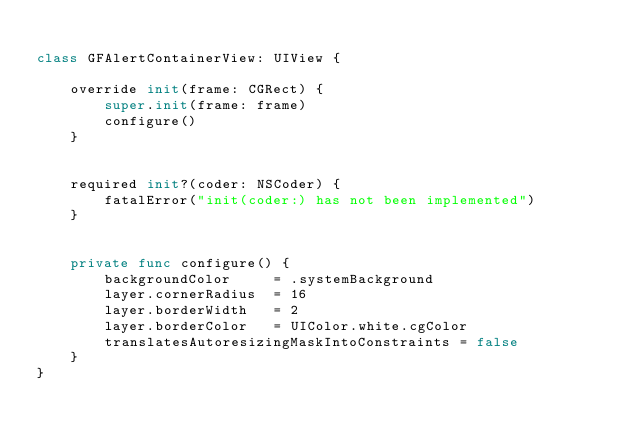Convert code to text. <code><loc_0><loc_0><loc_500><loc_500><_Swift_>
class GFAlertContainerView: UIView {

    override init(frame: CGRect) {
        super.init(frame: frame)
        configure()
    }
    
    
    required init?(coder: NSCoder) {
        fatalError("init(coder:) has not been implemented")
    }
    
    
    private func configure() {
        backgroundColor     = .systemBackground
        layer.cornerRadius  = 16
        layer.borderWidth   = 2
        layer.borderColor   = UIColor.white.cgColor
        translatesAutoresizingMaskIntoConstraints = false
    }
}
</code> 